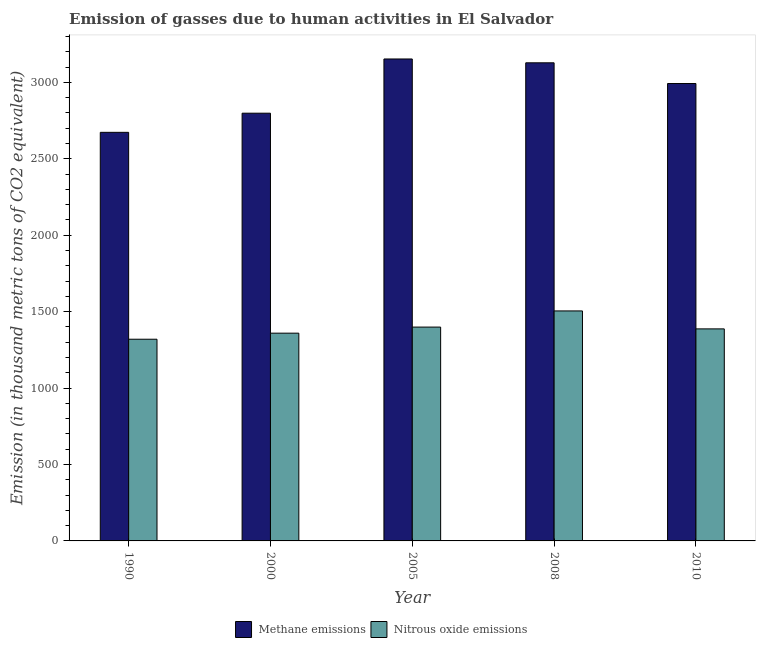How many different coloured bars are there?
Make the answer very short. 2. How many groups of bars are there?
Your answer should be compact. 5. Are the number of bars per tick equal to the number of legend labels?
Provide a short and direct response. Yes. Are the number of bars on each tick of the X-axis equal?
Your answer should be very brief. Yes. How many bars are there on the 3rd tick from the left?
Give a very brief answer. 2. What is the label of the 2nd group of bars from the left?
Provide a succinct answer. 2000. What is the amount of nitrous oxide emissions in 2000?
Ensure brevity in your answer.  1359.1. Across all years, what is the maximum amount of nitrous oxide emissions?
Make the answer very short. 1504.6. Across all years, what is the minimum amount of methane emissions?
Ensure brevity in your answer.  2672.9. In which year was the amount of nitrous oxide emissions minimum?
Offer a terse response. 1990. What is the total amount of methane emissions in the graph?
Give a very brief answer. 1.47e+04. What is the difference between the amount of methane emissions in 1990 and that in 2010?
Make the answer very short. -319.3. What is the difference between the amount of methane emissions in 2000 and the amount of nitrous oxide emissions in 2008?
Provide a succinct answer. -329.6. What is the average amount of methane emissions per year?
Your answer should be very brief. 2948.74. In the year 2000, what is the difference between the amount of nitrous oxide emissions and amount of methane emissions?
Your response must be concise. 0. What is the ratio of the amount of methane emissions in 2008 to that in 2010?
Offer a terse response. 1.05. Is the difference between the amount of nitrous oxide emissions in 2008 and 2010 greater than the difference between the amount of methane emissions in 2008 and 2010?
Keep it short and to the point. No. What is the difference between the highest and the second highest amount of nitrous oxide emissions?
Provide a succinct answer. 105.7. What is the difference between the highest and the lowest amount of nitrous oxide emissions?
Offer a very short reply. 185.2. What does the 2nd bar from the left in 2008 represents?
Your response must be concise. Nitrous oxide emissions. What does the 1st bar from the right in 2008 represents?
Offer a terse response. Nitrous oxide emissions. Are all the bars in the graph horizontal?
Offer a terse response. No. How are the legend labels stacked?
Your response must be concise. Horizontal. What is the title of the graph?
Give a very brief answer. Emission of gasses due to human activities in El Salvador. What is the label or title of the X-axis?
Make the answer very short. Year. What is the label or title of the Y-axis?
Ensure brevity in your answer.  Emission (in thousand metric tons of CO2 equivalent). What is the Emission (in thousand metric tons of CO2 equivalent) in Methane emissions in 1990?
Offer a very short reply. 2672.9. What is the Emission (in thousand metric tons of CO2 equivalent) in Nitrous oxide emissions in 1990?
Offer a very short reply. 1319.4. What is the Emission (in thousand metric tons of CO2 equivalent) in Methane emissions in 2000?
Make the answer very short. 2798.1. What is the Emission (in thousand metric tons of CO2 equivalent) in Nitrous oxide emissions in 2000?
Make the answer very short. 1359.1. What is the Emission (in thousand metric tons of CO2 equivalent) of Methane emissions in 2005?
Your response must be concise. 3152.8. What is the Emission (in thousand metric tons of CO2 equivalent) in Nitrous oxide emissions in 2005?
Your response must be concise. 1398.9. What is the Emission (in thousand metric tons of CO2 equivalent) in Methane emissions in 2008?
Keep it short and to the point. 3127.7. What is the Emission (in thousand metric tons of CO2 equivalent) in Nitrous oxide emissions in 2008?
Offer a very short reply. 1504.6. What is the Emission (in thousand metric tons of CO2 equivalent) of Methane emissions in 2010?
Make the answer very short. 2992.2. What is the Emission (in thousand metric tons of CO2 equivalent) of Nitrous oxide emissions in 2010?
Your answer should be very brief. 1387.1. Across all years, what is the maximum Emission (in thousand metric tons of CO2 equivalent) of Methane emissions?
Provide a short and direct response. 3152.8. Across all years, what is the maximum Emission (in thousand metric tons of CO2 equivalent) in Nitrous oxide emissions?
Your response must be concise. 1504.6. Across all years, what is the minimum Emission (in thousand metric tons of CO2 equivalent) in Methane emissions?
Ensure brevity in your answer.  2672.9. Across all years, what is the minimum Emission (in thousand metric tons of CO2 equivalent) of Nitrous oxide emissions?
Ensure brevity in your answer.  1319.4. What is the total Emission (in thousand metric tons of CO2 equivalent) of Methane emissions in the graph?
Make the answer very short. 1.47e+04. What is the total Emission (in thousand metric tons of CO2 equivalent) of Nitrous oxide emissions in the graph?
Give a very brief answer. 6969.1. What is the difference between the Emission (in thousand metric tons of CO2 equivalent) in Methane emissions in 1990 and that in 2000?
Offer a very short reply. -125.2. What is the difference between the Emission (in thousand metric tons of CO2 equivalent) in Nitrous oxide emissions in 1990 and that in 2000?
Your answer should be compact. -39.7. What is the difference between the Emission (in thousand metric tons of CO2 equivalent) of Methane emissions in 1990 and that in 2005?
Give a very brief answer. -479.9. What is the difference between the Emission (in thousand metric tons of CO2 equivalent) of Nitrous oxide emissions in 1990 and that in 2005?
Make the answer very short. -79.5. What is the difference between the Emission (in thousand metric tons of CO2 equivalent) in Methane emissions in 1990 and that in 2008?
Your answer should be compact. -454.8. What is the difference between the Emission (in thousand metric tons of CO2 equivalent) in Nitrous oxide emissions in 1990 and that in 2008?
Your answer should be compact. -185.2. What is the difference between the Emission (in thousand metric tons of CO2 equivalent) in Methane emissions in 1990 and that in 2010?
Offer a very short reply. -319.3. What is the difference between the Emission (in thousand metric tons of CO2 equivalent) in Nitrous oxide emissions in 1990 and that in 2010?
Your response must be concise. -67.7. What is the difference between the Emission (in thousand metric tons of CO2 equivalent) of Methane emissions in 2000 and that in 2005?
Your response must be concise. -354.7. What is the difference between the Emission (in thousand metric tons of CO2 equivalent) in Nitrous oxide emissions in 2000 and that in 2005?
Offer a terse response. -39.8. What is the difference between the Emission (in thousand metric tons of CO2 equivalent) in Methane emissions in 2000 and that in 2008?
Offer a very short reply. -329.6. What is the difference between the Emission (in thousand metric tons of CO2 equivalent) in Nitrous oxide emissions in 2000 and that in 2008?
Give a very brief answer. -145.5. What is the difference between the Emission (in thousand metric tons of CO2 equivalent) in Methane emissions in 2000 and that in 2010?
Make the answer very short. -194.1. What is the difference between the Emission (in thousand metric tons of CO2 equivalent) of Methane emissions in 2005 and that in 2008?
Offer a terse response. 25.1. What is the difference between the Emission (in thousand metric tons of CO2 equivalent) in Nitrous oxide emissions in 2005 and that in 2008?
Offer a terse response. -105.7. What is the difference between the Emission (in thousand metric tons of CO2 equivalent) of Methane emissions in 2005 and that in 2010?
Make the answer very short. 160.6. What is the difference between the Emission (in thousand metric tons of CO2 equivalent) in Methane emissions in 2008 and that in 2010?
Your answer should be very brief. 135.5. What is the difference between the Emission (in thousand metric tons of CO2 equivalent) in Nitrous oxide emissions in 2008 and that in 2010?
Ensure brevity in your answer.  117.5. What is the difference between the Emission (in thousand metric tons of CO2 equivalent) of Methane emissions in 1990 and the Emission (in thousand metric tons of CO2 equivalent) of Nitrous oxide emissions in 2000?
Offer a very short reply. 1313.8. What is the difference between the Emission (in thousand metric tons of CO2 equivalent) in Methane emissions in 1990 and the Emission (in thousand metric tons of CO2 equivalent) in Nitrous oxide emissions in 2005?
Keep it short and to the point. 1274. What is the difference between the Emission (in thousand metric tons of CO2 equivalent) of Methane emissions in 1990 and the Emission (in thousand metric tons of CO2 equivalent) of Nitrous oxide emissions in 2008?
Your response must be concise. 1168.3. What is the difference between the Emission (in thousand metric tons of CO2 equivalent) in Methane emissions in 1990 and the Emission (in thousand metric tons of CO2 equivalent) in Nitrous oxide emissions in 2010?
Provide a short and direct response. 1285.8. What is the difference between the Emission (in thousand metric tons of CO2 equivalent) in Methane emissions in 2000 and the Emission (in thousand metric tons of CO2 equivalent) in Nitrous oxide emissions in 2005?
Make the answer very short. 1399.2. What is the difference between the Emission (in thousand metric tons of CO2 equivalent) of Methane emissions in 2000 and the Emission (in thousand metric tons of CO2 equivalent) of Nitrous oxide emissions in 2008?
Give a very brief answer. 1293.5. What is the difference between the Emission (in thousand metric tons of CO2 equivalent) of Methane emissions in 2000 and the Emission (in thousand metric tons of CO2 equivalent) of Nitrous oxide emissions in 2010?
Provide a short and direct response. 1411. What is the difference between the Emission (in thousand metric tons of CO2 equivalent) of Methane emissions in 2005 and the Emission (in thousand metric tons of CO2 equivalent) of Nitrous oxide emissions in 2008?
Provide a succinct answer. 1648.2. What is the difference between the Emission (in thousand metric tons of CO2 equivalent) in Methane emissions in 2005 and the Emission (in thousand metric tons of CO2 equivalent) in Nitrous oxide emissions in 2010?
Provide a succinct answer. 1765.7. What is the difference between the Emission (in thousand metric tons of CO2 equivalent) of Methane emissions in 2008 and the Emission (in thousand metric tons of CO2 equivalent) of Nitrous oxide emissions in 2010?
Give a very brief answer. 1740.6. What is the average Emission (in thousand metric tons of CO2 equivalent) of Methane emissions per year?
Provide a short and direct response. 2948.74. What is the average Emission (in thousand metric tons of CO2 equivalent) in Nitrous oxide emissions per year?
Provide a short and direct response. 1393.82. In the year 1990, what is the difference between the Emission (in thousand metric tons of CO2 equivalent) of Methane emissions and Emission (in thousand metric tons of CO2 equivalent) of Nitrous oxide emissions?
Your response must be concise. 1353.5. In the year 2000, what is the difference between the Emission (in thousand metric tons of CO2 equivalent) of Methane emissions and Emission (in thousand metric tons of CO2 equivalent) of Nitrous oxide emissions?
Ensure brevity in your answer.  1439. In the year 2005, what is the difference between the Emission (in thousand metric tons of CO2 equivalent) of Methane emissions and Emission (in thousand metric tons of CO2 equivalent) of Nitrous oxide emissions?
Your response must be concise. 1753.9. In the year 2008, what is the difference between the Emission (in thousand metric tons of CO2 equivalent) in Methane emissions and Emission (in thousand metric tons of CO2 equivalent) in Nitrous oxide emissions?
Keep it short and to the point. 1623.1. In the year 2010, what is the difference between the Emission (in thousand metric tons of CO2 equivalent) in Methane emissions and Emission (in thousand metric tons of CO2 equivalent) in Nitrous oxide emissions?
Provide a succinct answer. 1605.1. What is the ratio of the Emission (in thousand metric tons of CO2 equivalent) in Methane emissions in 1990 to that in 2000?
Make the answer very short. 0.96. What is the ratio of the Emission (in thousand metric tons of CO2 equivalent) of Nitrous oxide emissions in 1990 to that in 2000?
Your response must be concise. 0.97. What is the ratio of the Emission (in thousand metric tons of CO2 equivalent) of Methane emissions in 1990 to that in 2005?
Your response must be concise. 0.85. What is the ratio of the Emission (in thousand metric tons of CO2 equivalent) in Nitrous oxide emissions in 1990 to that in 2005?
Make the answer very short. 0.94. What is the ratio of the Emission (in thousand metric tons of CO2 equivalent) in Methane emissions in 1990 to that in 2008?
Ensure brevity in your answer.  0.85. What is the ratio of the Emission (in thousand metric tons of CO2 equivalent) in Nitrous oxide emissions in 1990 to that in 2008?
Offer a terse response. 0.88. What is the ratio of the Emission (in thousand metric tons of CO2 equivalent) of Methane emissions in 1990 to that in 2010?
Your answer should be compact. 0.89. What is the ratio of the Emission (in thousand metric tons of CO2 equivalent) of Nitrous oxide emissions in 1990 to that in 2010?
Keep it short and to the point. 0.95. What is the ratio of the Emission (in thousand metric tons of CO2 equivalent) in Methane emissions in 2000 to that in 2005?
Give a very brief answer. 0.89. What is the ratio of the Emission (in thousand metric tons of CO2 equivalent) of Nitrous oxide emissions in 2000 to that in 2005?
Keep it short and to the point. 0.97. What is the ratio of the Emission (in thousand metric tons of CO2 equivalent) of Methane emissions in 2000 to that in 2008?
Ensure brevity in your answer.  0.89. What is the ratio of the Emission (in thousand metric tons of CO2 equivalent) in Nitrous oxide emissions in 2000 to that in 2008?
Your response must be concise. 0.9. What is the ratio of the Emission (in thousand metric tons of CO2 equivalent) of Methane emissions in 2000 to that in 2010?
Give a very brief answer. 0.94. What is the ratio of the Emission (in thousand metric tons of CO2 equivalent) of Nitrous oxide emissions in 2000 to that in 2010?
Provide a short and direct response. 0.98. What is the ratio of the Emission (in thousand metric tons of CO2 equivalent) of Methane emissions in 2005 to that in 2008?
Give a very brief answer. 1.01. What is the ratio of the Emission (in thousand metric tons of CO2 equivalent) of Nitrous oxide emissions in 2005 to that in 2008?
Offer a terse response. 0.93. What is the ratio of the Emission (in thousand metric tons of CO2 equivalent) in Methane emissions in 2005 to that in 2010?
Offer a very short reply. 1.05. What is the ratio of the Emission (in thousand metric tons of CO2 equivalent) in Nitrous oxide emissions in 2005 to that in 2010?
Offer a terse response. 1.01. What is the ratio of the Emission (in thousand metric tons of CO2 equivalent) of Methane emissions in 2008 to that in 2010?
Offer a very short reply. 1.05. What is the ratio of the Emission (in thousand metric tons of CO2 equivalent) in Nitrous oxide emissions in 2008 to that in 2010?
Ensure brevity in your answer.  1.08. What is the difference between the highest and the second highest Emission (in thousand metric tons of CO2 equivalent) of Methane emissions?
Your answer should be very brief. 25.1. What is the difference between the highest and the second highest Emission (in thousand metric tons of CO2 equivalent) in Nitrous oxide emissions?
Offer a terse response. 105.7. What is the difference between the highest and the lowest Emission (in thousand metric tons of CO2 equivalent) of Methane emissions?
Provide a succinct answer. 479.9. What is the difference between the highest and the lowest Emission (in thousand metric tons of CO2 equivalent) in Nitrous oxide emissions?
Keep it short and to the point. 185.2. 